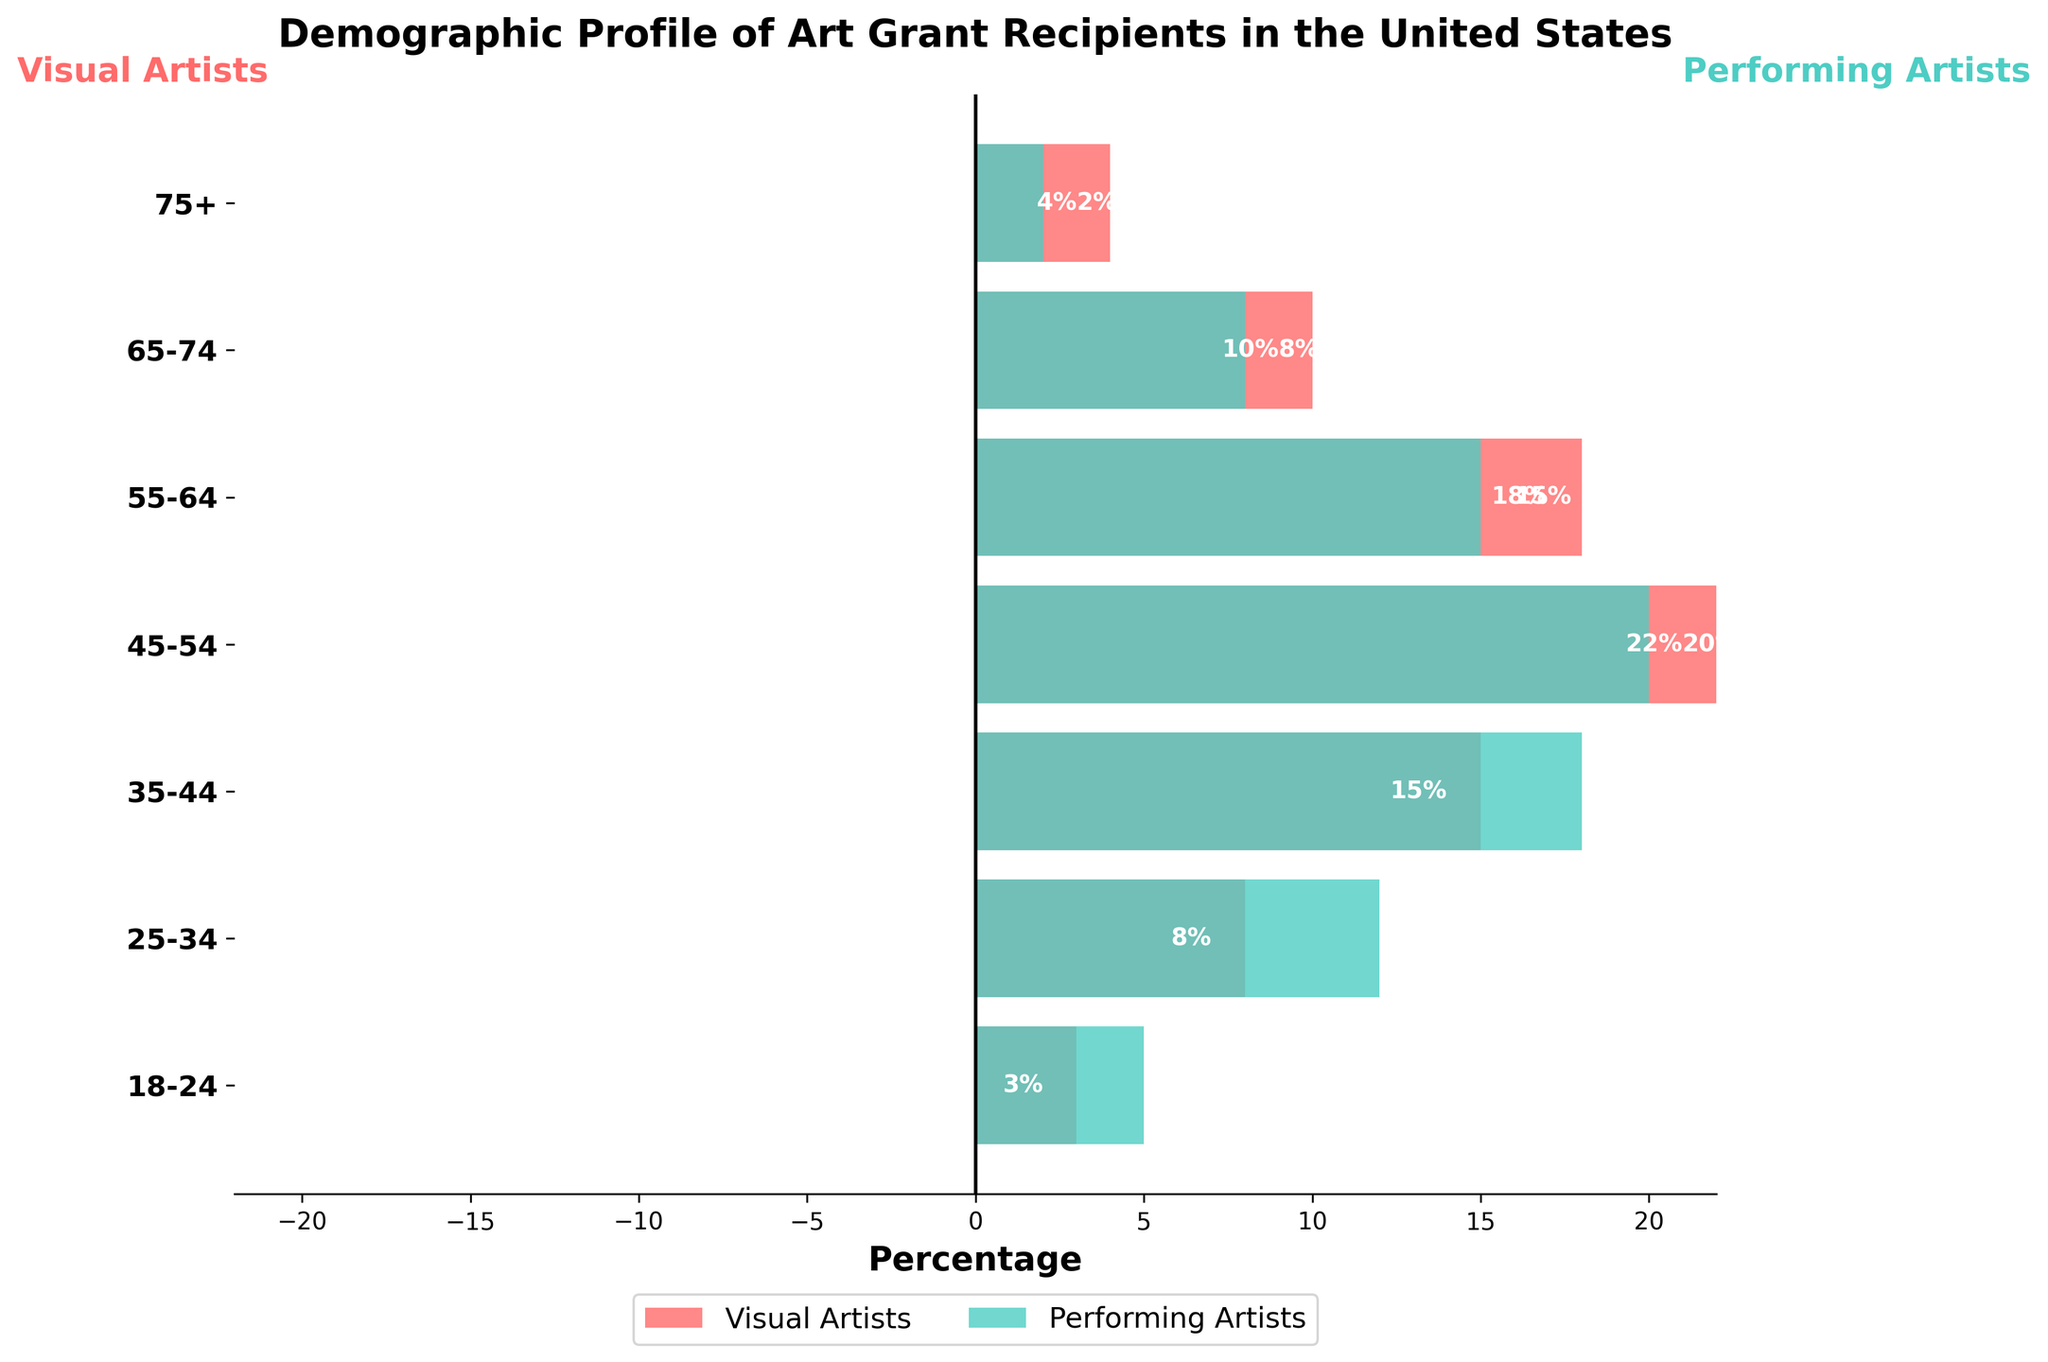Who receives the highest percentage of art grants in the 35-44 age group? By examining the bars for the 35-44 age group, the bar for Performing Artists extends further than for Visual Artists, indicating a higher percentage.
Answer: Performing Artists What is the title of the chart? The title is displayed at the top of the figure. It states the main focus of the figure.
Answer: Demographic Profile of Art Grant Recipients in the United States How many age groups are displayed in the figure? Each age group is represented by bars. Counting the distinct horizontal segments in the figure will reveal the number of age groups.
Answer: Seven In which age group do Visual Artists receive the least percentage of art grants? To find this, observe the bars representing Visual Artists and identify the smallest (most negative) percentage. The 45-54 age group has the bottommost bar for Visual Artists.
Answer: 45-54 Are there any age groups where the percentage of art grants given to Visual Artists is greater than Performing Artists? Each bar pair needs to be compared. None of the Visual Artists' bars extend further to the right of the central vertical line than the Performing Artists' bars extend to the left.
Answer: No What is the difference in percentage of art grants received by Visual Artists and Performing Artists in the 55-64 age group? Locate the bars for the 55-64 age group, note their absolute values (18 for Visual and 15 for Performing), and calculate the difference.
Answer: 3% Which group has a higher overall spread in grant percentages across all age groups? For each age group, compare the Visual and Performing Artists' bars. Performing Artists have consistently higher values.
Answer: Performing Artists How does the grant percentage distribution change for Visual Artists as age increases? Trace the trend of the Visual Artists’ bars from the youngest to the oldest age group. They gradually increase in magnitude up to 45-54, then decrease thereafter.
Answer: Increase, then decrease after 45-54 What is the sum of percentages for Performing Artists in the 25-34 and 65-74 age groups? Add the Performing Artists' percentages for these two groups by summing 12 and 8.
Answer: 20 Which age group has the most equal grant percentages between Visual and Performing Artists? Compare the magnitude of paired bars for all age groups to find the pair with the smallest difference in length. The 75+ age group has a 2% difference.
Answer: 75+ 